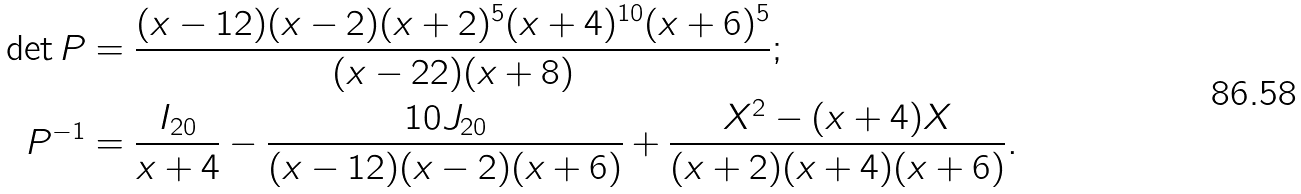Convert formula to latex. <formula><loc_0><loc_0><loc_500><loc_500>\det P & = \frac { ( x - 1 2 ) ( x - 2 ) ( x + 2 ) ^ { 5 } ( x + 4 ) ^ { 1 0 } ( x + 6 ) ^ { 5 } } { ( x - 2 2 ) ( x + 8 ) } ; \\ P ^ { - 1 } & = \frac { I _ { 2 0 } } { x + 4 } - \frac { 1 0 J _ { 2 0 } } { ( x - 1 2 ) ( x - 2 ) ( x + 6 ) } + \frac { X ^ { 2 } - ( x + 4 ) X } { ( x + 2 ) ( x + 4 ) ( x + 6 ) } .</formula> 